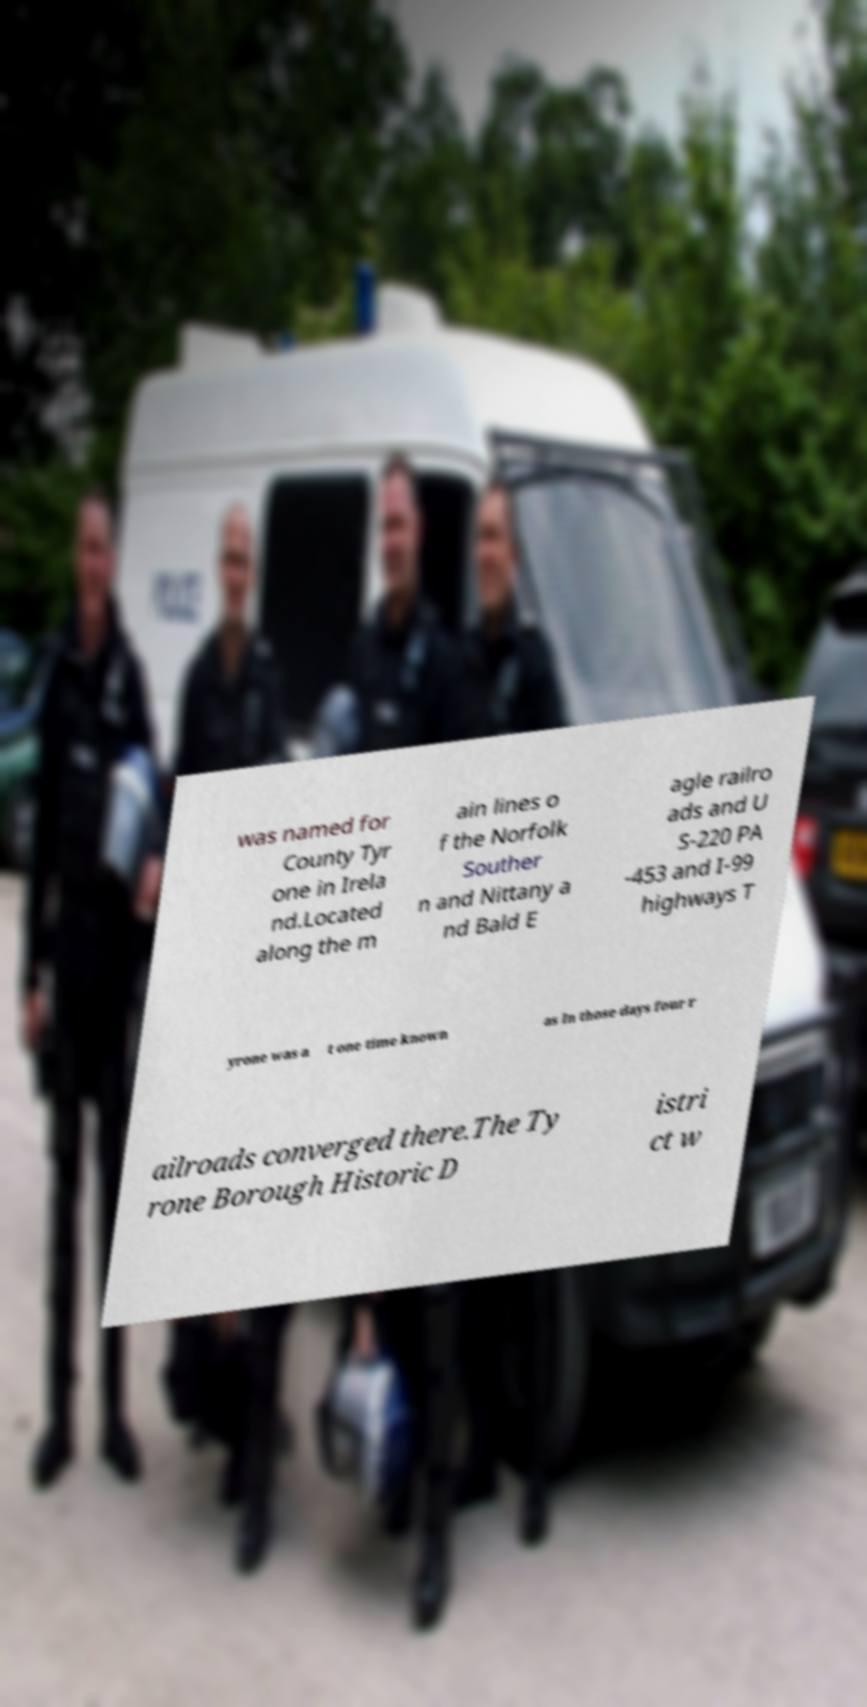Could you extract and type out the text from this image? was named for County Tyr one in Irela nd.Located along the m ain lines o f the Norfolk Souther n and Nittany a nd Bald E agle railro ads and U S-220 PA -453 and I-99 highways T yrone was a t one time known as In those days four r ailroads converged there.The Ty rone Borough Historic D istri ct w 